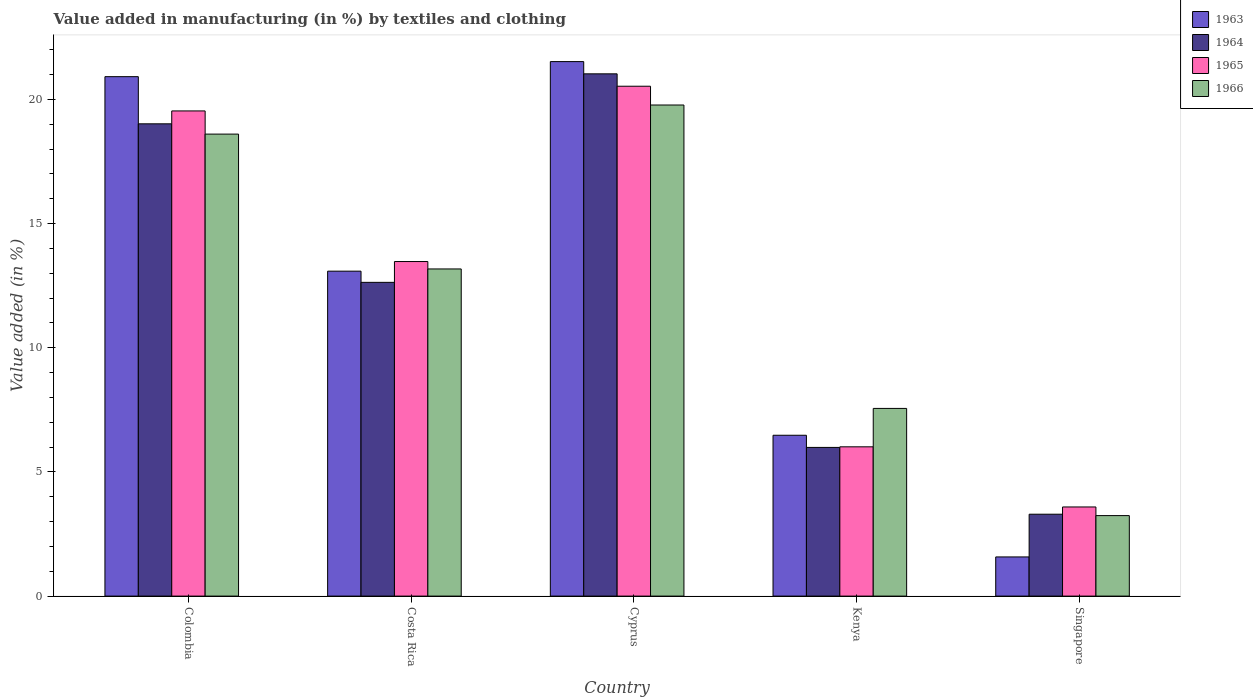How many different coloured bars are there?
Your response must be concise. 4. Are the number of bars per tick equal to the number of legend labels?
Ensure brevity in your answer.  Yes. How many bars are there on the 1st tick from the left?
Your response must be concise. 4. How many bars are there on the 5th tick from the right?
Your answer should be compact. 4. In how many cases, is the number of bars for a given country not equal to the number of legend labels?
Keep it short and to the point. 0. What is the percentage of value added in manufacturing by textiles and clothing in 1966 in Kenya?
Your answer should be very brief. 7.56. Across all countries, what is the maximum percentage of value added in manufacturing by textiles and clothing in 1965?
Keep it short and to the point. 20.53. Across all countries, what is the minimum percentage of value added in manufacturing by textiles and clothing in 1966?
Ensure brevity in your answer.  3.24. In which country was the percentage of value added in manufacturing by textiles and clothing in 1966 maximum?
Provide a short and direct response. Cyprus. In which country was the percentage of value added in manufacturing by textiles and clothing in 1966 minimum?
Offer a terse response. Singapore. What is the total percentage of value added in manufacturing by textiles and clothing in 1965 in the graph?
Keep it short and to the point. 63.14. What is the difference between the percentage of value added in manufacturing by textiles and clothing in 1964 in Colombia and that in Cyprus?
Your response must be concise. -2.01. What is the difference between the percentage of value added in manufacturing by textiles and clothing in 1963 in Costa Rica and the percentage of value added in manufacturing by textiles and clothing in 1964 in Singapore?
Your answer should be very brief. 9.79. What is the average percentage of value added in manufacturing by textiles and clothing in 1965 per country?
Offer a terse response. 12.63. What is the difference between the percentage of value added in manufacturing by textiles and clothing of/in 1964 and percentage of value added in manufacturing by textiles and clothing of/in 1966 in Colombia?
Offer a very short reply. 0.41. What is the ratio of the percentage of value added in manufacturing by textiles and clothing in 1965 in Costa Rica to that in Singapore?
Your response must be concise. 3.75. Is the percentage of value added in manufacturing by textiles and clothing in 1964 in Colombia less than that in Cyprus?
Keep it short and to the point. Yes. Is the difference between the percentage of value added in manufacturing by textiles and clothing in 1964 in Costa Rica and Singapore greater than the difference between the percentage of value added in manufacturing by textiles and clothing in 1966 in Costa Rica and Singapore?
Make the answer very short. No. What is the difference between the highest and the second highest percentage of value added in manufacturing by textiles and clothing in 1964?
Provide a short and direct response. 6.38. What is the difference between the highest and the lowest percentage of value added in manufacturing by textiles and clothing in 1964?
Provide a short and direct response. 17.73. Is the sum of the percentage of value added in manufacturing by textiles and clothing in 1965 in Colombia and Cyprus greater than the maximum percentage of value added in manufacturing by textiles and clothing in 1964 across all countries?
Your answer should be very brief. Yes. Is it the case that in every country, the sum of the percentage of value added in manufacturing by textiles and clothing in 1963 and percentage of value added in manufacturing by textiles and clothing in 1964 is greater than the sum of percentage of value added in manufacturing by textiles and clothing in 1966 and percentage of value added in manufacturing by textiles and clothing in 1965?
Provide a short and direct response. No. What does the 4th bar from the right in Cyprus represents?
Provide a succinct answer. 1963. How many countries are there in the graph?
Your answer should be compact. 5. Does the graph contain any zero values?
Offer a very short reply. No. Does the graph contain grids?
Provide a succinct answer. No. How are the legend labels stacked?
Your answer should be compact. Vertical. What is the title of the graph?
Offer a terse response. Value added in manufacturing (in %) by textiles and clothing. Does "1975" appear as one of the legend labels in the graph?
Ensure brevity in your answer.  No. What is the label or title of the X-axis?
Provide a short and direct response. Country. What is the label or title of the Y-axis?
Your answer should be very brief. Value added (in %). What is the Value added (in %) in 1963 in Colombia?
Provide a succinct answer. 20.92. What is the Value added (in %) of 1964 in Colombia?
Your response must be concise. 19.02. What is the Value added (in %) of 1965 in Colombia?
Ensure brevity in your answer.  19.54. What is the Value added (in %) in 1966 in Colombia?
Offer a very short reply. 18.6. What is the Value added (in %) in 1963 in Costa Rica?
Offer a terse response. 13.08. What is the Value added (in %) in 1964 in Costa Rica?
Keep it short and to the point. 12.63. What is the Value added (in %) of 1965 in Costa Rica?
Provide a short and direct response. 13.47. What is the Value added (in %) in 1966 in Costa Rica?
Offer a terse response. 13.17. What is the Value added (in %) of 1963 in Cyprus?
Make the answer very short. 21.52. What is the Value added (in %) in 1964 in Cyprus?
Provide a succinct answer. 21.03. What is the Value added (in %) in 1965 in Cyprus?
Your answer should be very brief. 20.53. What is the Value added (in %) in 1966 in Cyprus?
Your answer should be very brief. 19.78. What is the Value added (in %) in 1963 in Kenya?
Offer a terse response. 6.48. What is the Value added (in %) of 1964 in Kenya?
Offer a very short reply. 5.99. What is the Value added (in %) in 1965 in Kenya?
Offer a terse response. 6.01. What is the Value added (in %) in 1966 in Kenya?
Provide a succinct answer. 7.56. What is the Value added (in %) of 1963 in Singapore?
Provide a succinct answer. 1.58. What is the Value added (in %) of 1964 in Singapore?
Give a very brief answer. 3.3. What is the Value added (in %) in 1965 in Singapore?
Your answer should be compact. 3.59. What is the Value added (in %) of 1966 in Singapore?
Offer a very short reply. 3.24. Across all countries, what is the maximum Value added (in %) of 1963?
Give a very brief answer. 21.52. Across all countries, what is the maximum Value added (in %) in 1964?
Provide a succinct answer. 21.03. Across all countries, what is the maximum Value added (in %) of 1965?
Offer a terse response. 20.53. Across all countries, what is the maximum Value added (in %) of 1966?
Make the answer very short. 19.78. Across all countries, what is the minimum Value added (in %) in 1963?
Your response must be concise. 1.58. Across all countries, what is the minimum Value added (in %) in 1964?
Make the answer very short. 3.3. Across all countries, what is the minimum Value added (in %) in 1965?
Your answer should be compact. 3.59. Across all countries, what is the minimum Value added (in %) in 1966?
Provide a succinct answer. 3.24. What is the total Value added (in %) of 1963 in the graph?
Offer a terse response. 63.58. What is the total Value added (in %) in 1964 in the graph?
Your answer should be very brief. 61.97. What is the total Value added (in %) in 1965 in the graph?
Provide a short and direct response. 63.14. What is the total Value added (in %) of 1966 in the graph?
Ensure brevity in your answer.  62.35. What is the difference between the Value added (in %) in 1963 in Colombia and that in Costa Rica?
Keep it short and to the point. 7.83. What is the difference between the Value added (in %) in 1964 in Colombia and that in Costa Rica?
Provide a succinct answer. 6.38. What is the difference between the Value added (in %) of 1965 in Colombia and that in Costa Rica?
Keep it short and to the point. 6.06. What is the difference between the Value added (in %) of 1966 in Colombia and that in Costa Rica?
Offer a terse response. 5.43. What is the difference between the Value added (in %) of 1963 in Colombia and that in Cyprus?
Offer a terse response. -0.61. What is the difference between the Value added (in %) of 1964 in Colombia and that in Cyprus?
Offer a terse response. -2.01. What is the difference between the Value added (in %) in 1965 in Colombia and that in Cyprus?
Your answer should be very brief. -0.99. What is the difference between the Value added (in %) of 1966 in Colombia and that in Cyprus?
Provide a succinct answer. -1.17. What is the difference between the Value added (in %) of 1963 in Colombia and that in Kenya?
Offer a terse response. 14.44. What is the difference between the Value added (in %) in 1964 in Colombia and that in Kenya?
Make the answer very short. 13.03. What is the difference between the Value added (in %) in 1965 in Colombia and that in Kenya?
Provide a short and direct response. 13.53. What is the difference between the Value added (in %) of 1966 in Colombia and that in Kenya?
Give a very brief answer. 11.05. What is the difference between the Value added (in %) in 1963 in Colombia and that in Singapore?
Ensure brevity in your answer.  19.34. What is the difference between the Value added (in %) of 1964 in Colombia and that in Singapore?
Ensure brevity in your answer.  15.72. What is the difference between the Value added (in %) of 1965 in Colombia and that in Singapore?
Offer a very short reply. 15.95. What is the difference between the Value added (in %) in 1966 in Colombia and that in Singapore?
Give a very brief answer. 15.36. What is the difference between the Value added (in %) in 1963 in Costa Rica and that in Cyprus?
Provide a short and direct response. -8.44. What is the difference between the Value added (in %) in 1964 in Costa Rica and that in Cyprus?
Your answer should be compact. -8.4. What is the difference between the Value added (in %) in 1965 in Costa Rica and that in Cyprus?
Offer a terse response. -7.06. What is the difference between the Value added (in %) in 1966 in Costa Rica and that in Cyprus?
Your answer should be compact. -6.6. What is the difference between the Value added (in %) in 1963 in Costa Rica and that in Kenya?
Provide a succinct answer. 6.61. What is the difference between the Value added (in %) in 1964 in Costa Rica and that in Kenya?
Make the answer very short. 6.65. What is the difference between the Value added (in %) in 1965 in Costa Rica and that in Kenya?
Ensure brevity in your answer.  7.46. What is the difference between the Value added (in %) in 1966 in Costa Rica and that in Kenya?
Provide a short and direct response. 5.62. What is the difference between the Value added (in %) in 1963 in Costa Rica and that in Singapore?
Provide a succinct answer. 11.51. What is the difference between the Value added (in %) in 1964 in Costa Rica and that in Singapore?
Your response must be concise. 9.34. What is the difference between the Value added (in %) in 1965 in Costa Rica and that in Singapore?
Make the answer very short. 9.88. What is the difference between the Value added (in %) of 1966 in Costa Rica and that in Singapore?
Make the answer very short. 9.93. What is the difference between the Value added (in %) in 1963 in Cyprus and that in Kenya?
Provide a succinct answer. 15.05. What is the difference between the Value added (in %) of 1964 in Cyprus and that in Kenya?
Make the answer very short. 15.04. What is the difference between the Value added (in %) in 1965 in Cyprus and that in Kenya?
Give a very brief answer. 14.52. What is the difference between the Value added (in %) in 1966 in Cyprus and that in Kenya?
Offer a terse response. 12.22. What is the difference between the Value added (in %) of 1963 in Cyprus and that in Singapore?
Keep it short and to the point. 19.95. What is the difference between the Value added (in %) in 1964 in Cyprus and that in Singapore?
Offer a very short reply. 17.73. What is the difference between the Value added (in %) of 1965 in Cyprus and that in Singapore?
Your answer should be very brief. 16.94. What is the difference between the Value added (in %) of 1966 in Cyprus and that in Singapore?
Your answer should be very brief. 16.53. What is the difference between the Value added (in %) in 1963 in Kenya and that in Singapore?
Your answer should be compact. 4.9. What is the difference between the Value added (in %) of 1964 in Kenya and that in Singapore?
Offer a very short reply. 2.69. What is the difference between the Value added (in %) in 1965 in Kenya and that in Singapore?
Your answer should be compact. 2.42. What is the difference between the Value added (in %) in 1966 in Kenya and that in Singapore?
Provide a succinct answer. 4.32. What is the difference between the Value added (in %) of 1963 in Colombia and the Value added (in %) of 1964 in Costa Rica?
Provide a short and direct response. 8.28. What is the difference between the Value added (in %) of 1963 in Colombia and the Value added (in %) of 1965 in Costa Rica?
Your answer should be compact. 7.44. What is the difference between the Value added (in %) in 1963 in Colombia and the Value added (in %) in 1966 in Costa Rica?
Your answer should be very brief. 7.74. What is the difference between the Value added (in %) in 1964 in Colombia and the Value added (in %) in 1965 in Costa Rica?
Your answer should be compact. 5.55. What is the difference between the Value added (in %) of 1964 in Colombia and the Value added (in %) of 1966 in Costa Rica?
Your response must be concise. 5.84. What is the difference between the Value added (in %) of 1965 in Colombia and the Value added (in %) of 1966 in Costa Rica?
Keep it short and to the point. 6.36. What is the difference between the Value added (in %) of 1963 in Colombia and the Value added (in %) of 1964 in Cyprus?
Ensure brevity in your answer.  -0.11. What is the difference between the Value added (in %) of 1963 in Colombia and the Value added (in %) of 1965 in Cyprus?
Your response must be concise. 0.39. What is the difference between the Value added (in %) of 1963 in Colombia and the Value added (in %) of 1966 in Cyprus?
Offer a very short reply. 1.14. What is the difference between the Value added (in %) of 1964 in Colombia and the Value added (in %) of 1965 in Cyprus?
Keep it short and to the point. -1.51. What is the difference between the Value added (in %) in 1964 in Colombia and the Value added (in %) in 1966 in Cyprus?
Provide a succinct answer. -0.76. What is the difference between the Value added (in %) in 1965 in Colombia and the Value added (in %) in 1966 in Cyprus?
Give a very brief answer. -0.24. What is the difference between the Value added (in %) of 1963 in Colombia and the Value added (in %) of 1964 in Kenya?
Offer a terse response. 14.93. What is the difference between the Value added (in %) of 1963 in Colombia and the Value added (in %) of 1965 in Kenya?
Keep it short and to the point. 14.91. What is the difference between the Value added (in %) in 1963 in Colombia and the Value added (in %) in 1966 in Kenya?
Your answer should be very brief. 13.36. What is the difference between the Value added (in %) in 1964 in Colombia and the Value added (in %) in 1965 in Kenya?
Your answer should be very brief. 13.01. What is the difference between the Value added (in %) of 1964 in Colombia and the Value added (in %) of 1966 in Kenya?
Offer a very short reply. 11.46. What is the difference between the Value added (in %) of 1965 in Colombia and the Value added (in %) of 1966 in Kenya?
Provide a succinct answer. 11.98. What is the difference between the Value added (in %) in 1963 in Colombia and the Value added (in %) in 1964 in Singapore?
Provide a short and direct response. 17.62. What is the difference between the Value added (in %) in 1963 in Colombia and the Value added (in %) in 1965 in Singapore?
Provide a succinct answer. 17.33. What is the difference between the Value added (in %) in 1963 in Colombia and the Value added (in %) in 1966 in Singapore?
Your answer should be very brief. 17.68. What is the difference between the Value added (in %) of 1964 in Colombia and the Value added (in %) of 1965 in Singapore?
Your response must be concise. 15.43. What is the difference between the Value added (in %) of 1964 in Colombia and the Value added (in %) of 1966 in Singapore?
Your answer should be compact. 15.78. What is the difference between the Value added (in %) in 1965 in Colombia and the Value added (in %) in 1966 in Singapore?
Make the answer very short. 16.3. What is the difference between the Value added (in %) in 1963 in Costa Rica and the Value added (in %) in 1964 in Cyprus?
Offer a very short reply. -7.95. What is the difference between the Value added (in %) of 1963 in Costa Rica and the Value added (in %) of 1965 in Cyprus?
Your response must be concise. -7.45. What is the difference between the Value added (in %) of 1963 in Costa Rica and the Value added (in %) of 1966 in Cyprus?
Make the answer very short. -6.69. What is the difference between the Value added (in %) in 1964 in Costa Rica and the Value added (in %) in 1965 in Cyprus?
Your answer should be compact. -7.9. What is the difference between the Value added (in %) in 1964 in Costa Rica and the Value added (in %) in 1966 in Cyprus?
Make the answer very short. -7.14. What is the difference between the Value added (in %) of 1965 in Costa Rica and the Value added (in %) of 1966 in Cyprus?
Provide a succinct answer. -6.3. What is the difference between the Value added (in %) of 1963 in Costa Rica and the Value added (in %) of 1964 in Kenya?
Your response must be concise. 7.1. What is the difference between the Value added (in %) of 1963 in Costa Rica and the Value added (in %) of 1965 in Kenya?
Your answer should be very brief. 7.07. What is the difference between the Value added (in %) in 1963 in Costa Rica and the Value added (in %) in 1966 in Kenya?
Keep it short and to the point. 5.53. What is the difference between the Value added (in %) of 1964 in Costa Rica and the Value added (in %) of 1965 in Kenya?
Offer a terse response. 6.62. What is the difference between the Value added (in %) of 1964 in Costa Rica and the Value added (in %) of 1966 in Kenya?
Provide a succinct answer. 5.08. What is the difference between the Value added (in %) of 1965 in Costa Rica and the Value added (in %) of 1966 in Kenya?
Your response must be concise. 5.91. What is the difference between the Value added (in %) in 1963 in Costa Rica and the Value added (in %) in 1964 in Singapore?
Ensure brevity in your answer.  9.79. What is the difference between the Value added (in %) in 1963 in Costa Rica and the Value added (in %) in 1965 in Singapore?
Your answer should be very brief. 9.5. What is the difference between the Value added (in %) in 1963 in Costa Rica and the Value added (in %) in 1966 in Singapore?
Your answer should be very brief. 9.84. What is the difference between the Value added (in %) in 1964 in Costa Rica and the Value added (in %) in 1965 in Singapore?
Your answer should be compact. 9.04. What is the difference between the Value added (in %) of 1964 in Costa Rica and the Value added (in %) of 1966 in Singapore?
Provide a short and direct response. 9.39. What is the difference between the Value added (in %) in 1965 in Costa Rica and the Value added (in %) in 1966 in Singapore?
Give a very brief answer. 10.23. What is the difference between the Value added (in %) of 1963 in Cyprus and the Value added (in %) of 1964 in Kenya?
Offer a very short reply. 15.54. What is the difference between the Value added (in %) in 1963 in Cyprus and the Value added (in %) in 1965 in Kenya?
Ensure brevity in your answer.  15.51. What is the difference between the Value added (in %) of 1963 in Cyprus and the Value added (in %) of 1966 in Kenya?
Keep it short and to the point. 13.97. What is the difference between the Value added (in %) of 1964 in Cyprus and the Value added (in %) of 1965 in Kenya?
Give a very brief answer. 15.02. What is the difference between the Value added (in %) in 1964 in Cyprus and the Value added (in %) in 1966 in Kenya?
Give a very brief answer. 13.47. What is the difference between the Value added (in %) in 1965 in Cyprus and the Value added (in %) in 1966 in Kenya?
Your answer should be compact. 12.97. What is the difference between the Value added (in %) in 1963 in Cyprus and the Value added (in %) in 1964 in Singapore?
Provide a short and direct response. 18.23. What is the difference between the Value added (in %) of 1963 in Cyprus and the Value added (in %) of 1965 in Singapore?
Your answer should be very brief. 17.93. What is the difference between the Value added (in %) in 1963 in Cyprus and the Value added (in %) in 1966 in Singapore?
Your answer should be very brief. 18.28. What is the difference between the Value added (in %) of 1964 in Cyprus and the Value added (in %) of 1965 in Singapore?
Ensure brevity in your answer.  17.44. What is the difference between the Value added (in %) of 1964 in Cyprus and the Value added (in %) of 1966 in Singapore?
Give a very brief answer. 17.79. What is the difference between the Value added (in %) in 1965 in Cyprus and the Value added (in %) in 1966 in Singapore?
Give a very brief answer. 17.29. What is the difference between the Value added (in %) of 1963 in Kenya and the Value added (in %) of 1964 in Singapore?
Give a very brief answer. 3.18. What is the difference between the Value added (in %) in 1963 in Kenya and the Value added (in %) in 1965 in Singapore?
Give a very brief answer. 2.89. What is the difference between the Value added (in %) in 1963 in Kenya and the Value added (in %) in 1966 in Singapore?
Give a very brief answer. 3.24. What is the difference between the Value added (in %) in 1964 in Kenya and the Value added (in %) in 1965 in Singapore?
Offer a terse response. 2.4. What is the difference between the Value added (in %) of 1964 in Kenya and the Value added (in %) of 1966 in Singapore?
Ensure brevity in your answer.  2.75. What is the difference between the Value added (in %) in 1965 in Kenya and the Value added (in %) in 1966 in Singapore?
Your answer should be very brief. 2.77. What is the average Value added (in %) of 1963 per country?
Your answer should be very brief. 12.72. What is the average Value added (in %) of 1964 per country?
Ensure brevity in your answer.  12.39. What is the average Value added (in %) of 1965 per country?
Provide a succinct answer. 12.63. What is the average Value added (in %) of 1966 per country?
Ensure brevity in your answer.  12.47. What is the difference between the Value added (in %) of 1963 and Value added (in %) of 1964 in Colombia?
Offer a terse response. 1.9. What is the difference between the Value added (in %) of 1963 and Value added (in %) of 1965 in Colombia?
Give a very brief answer. 1.38. What is the difference between the Value added (in %) of 1963 and Value added (in %) of 1966 in Colombia?
Keep it short and to the point. 2.31. What is the difference between the Value added (in %) in 1964 and Value added (in %) in 1965 in Colombia?
Give a very brief answer. -0.52. What is the difference between the Value added (in %) of 1964 and Value added (in %) of 1966 in Colombia?
Make the answer very short. 0.41. What is the difference between the Value added (in %) of 1965 and Value added (in %) of 1966 in Colombia?
Give a very brief answer. 0.93. What is the difference between the Value added (in %) of 1963 and Value added (in %) of 1964 in Costa Rica?
Ensure brevity in your answer.  0.45. What is the difference between the Value added (in %) of 1963 and Value added (in %) of 1965 in Costa Rica?
Your answer should be compact. -0.39. What is the difference between the Value added (in %) in 1963 and Value added (in %) in 1966 in Costa Rica?
Keep it short and to the point. -0.09. What is the difference between the Value added (in %) in 1964 and Value added (in %) in 1965 in Costa Rica?
Give a very brief answer. -0.84. What is the difference between the Value added (in %) in 1964 and Value added (in %) in 1966 in Costa Rica?
Provide a succinct answer. -0.54. What is the difference between the Value added (in %) of 1965 and Value added (in %) of 1966 in Costa Rica?
Offer a very short reply. 0.3. What is the difference between the Value added (in %) in 1963 and Value added (in %) in 1964 in Cyprus?
Provide a succinct answer. 0.49. What is the difference between the Value added (in %) of 1963 and Value added (in %) of 1966 in Cyprus?
Provide a succinct answer. 1.75. What is the difference between the Value added (in %) in 1964 and Value added (in %) in 1965 in Cyprus?
Provide a succinct answer. 0.5. What is the difference between the Value added (in %) in 1964 and Value added (in %) in 1966 in Cyprus?
Make the answer very short. 1.25. What is the difference between the Value added (in %) in 1965 and Value added (in %) in 1966 in Cyprus?
Ensure brevity in your answer.  0.76. What is the difference between the Value added (in %) of 1963 and Value added (in %) of 1964 in Kenya?
Keep it short and to the point. 0.49. What is the difference between the Value added (in %) in 1963 and Value added (in %) in 1965 in Kenya?
Keep it short and to the point. 0.47. What is the difference between the Value added (in %) of 1963 and Value added (in %) of 1966 in Kenya?
Keep it short and to the point. -1.08. What is the difference between the Value added (in %) of 1964 and Value added (in %) of 1965 in Kenya?
Offer a very short reply. -0.02. What is the difference between the Value added (in %) in 1964 and Value added (in %) in 1966 in Kenya?
Ensure brevity in your answer.  -1.57. What is the difference between the Value added (in %) of 1965 and Value added (in %) of 1966 in Kenya?
Keep it short and to the point. -1.55. What is the difference between the Value added (in %) in 1963 and Value added (in %) in 1964 in Singapore?
Provide a short and direct response. -1.72. What is the difference between the Value added (in %) in 1963 and Value added (in %) in 1965 in Singapore?
Offer a very short reply. -2.01. What is the difference between the Value added (in %) in 1963 and Value added (in %) in 1966 in Singapore?
Give a very brief answer. -1.66. What is the difference between the Value added (in %) of 1964 and Value added (in %) of 1965 in Singapore?
Make the answer very short. -0.29. What is the difference between the Value added (in %) of 1964 and Value added (in %) of 1966 in Singapore?
Your response must be concise. 0.06. What is the difference between the Value added (in %) of 1965 and Value added (in %) of 1966 in Singapore?
Provide a short and direct response. 0.35. What is the ratio of the Value added (in %) of 1963 in Colombia to that in Costa Rica?
Provide a succinct answer. 1.6. What is the ratio of the Value added (in %) of 1964 in Colombia to that in Costa Rica?
Your answer should be very brief. 1.51. What is the ratio of the Value added (in %) in 1965 in Colombia to that in Costa Rica?
Make the answer very short. 1.45. What is the ratio of the Value added (in %) of 1966 in Colombia to that in Costa Rica?
Provide a succinct answer. 1.41. What is the ratio of the Value added (in %) in 1963 in Colombia to that in Cyprus?
Keep it short and to the point. 0.97. What is the ratio of the Value added (in %) of 1964 in Colombia to that in Cyprus?
Provide a short and direct response. 0.9. What is the ratio of the Value added (in %) in 1965 in Colombia to that in Cyprus?
Offer a terse response. 0.95. What is the ratio of the Value added (in %) in 1966 in Colombia to that in Cyprus?
Offer a terse response. 0.94. What is the ratio of the Value added (in %) in 1963 in Colombia to that in Kenya?
Your answer should be very brief. 3.23. What is the ratio of the Value added (in %) of 1964 in Colombia to that in Kenya?
Give a very brief answer. 3.18. What is the ratio of the Value added (in %) in 1965 in Colombia to that in Kenya?
Offer a very short reply. 3.25. What is the ratio of the Value added (in %) in 1966 in Colombia to that in Kenya?
Give a very brief answer. 2.46. What is the ratio of the Value added (in %) of 1963 in Colombia to that in Singapore?
Your response must be concise. 13.26. What is the ratio of the Value added (in %) in 1964 in Colombia to that in Singapore?
Your answer should be very brief. 5.77. What is the ratio of the Value added (in %) in 1965 in Colombia to that in Singapore?
Your response must be concise. 5.44. What is the ratio of the Value added (in %) of 1966 in Colombia to that in Singapore?
Your answer should be compact. 5.74. What is the ratio of the Value added (in %) of 1963 in Costa Rica to that in Cyprus?
Ensure brevity in your answer.  0.61. What is the ratio of the Value added (in %) in 1964 in Costa Rica to that in Cyprus?
Ensure brevity in your answer.  0.6. What is the ratio of the Value added (in %) of 1965 in Costa Rica to that in Cyprus?
Offer a terse response. 0.66. What is the ratio of the Value added (in %) of 1966 in Costa Rica to that in Cyprus?
Ensure brevity in your answer.  0.67. What is the ratio of the Value added (in %) of 1963 in Costa Rica to that in Kenya?
Keep it short and to the point. 2.02. What is the ratio of the Value added (in %) in 1964 in Costa Rica to that in Kenya?
Provide a short and direct response. 2.11. What is the ratio of the Value added (in %) in 1965 in Costa Rica to that in Kenya?
Your response must be concise. 2.24. What is the ratio of the Value added (in %) in 1966 in Costa Rica to that in Kenya?
Your response must be concise. 1.74. What is the ratio of the Value added (in %) in 1963 in Costa Rica to that in Singapore?
Your response must be concise. 8.3. What is the ratio of the Value added (in %) of 1964 in Costa Rica to that in Singapore?
Ensure brevity in your answer.  3.83. What is the ratio of the Value added (in %) in 1965 in Costa Rica to that in Singapore?
Ensure brevity in your answer.  3.75. What is the ratio of the Value added (in %) in 1966 in Costa Rica to that in Singapore?
Offer a terse response. 4.06. What is the ratio of the Value added (in %) of 1963 in Cyprus to that in Kenya?
Your response must be concise. 3.32. What is the ratio of the Value added (in %) in 1964 in Cyprus to that in Kenya?
Ensure brevity in your answer.  3.51. What is the ratio of the Value added (in %) of 1965 in Cyprus to that in Kenya?
Your answer should be compact. 3.42. What is the ratio of the Value added (in %) in 1966 in Cyprus to that in Kenya?
Give a very brief answer. 2.62. What is the ratio of the Value added (in %) in 1963 in Cyprus to that in Singapore?
Your answer should be very brief. 13.65. What is the ratio of the Value added (in %) in 1964 in Cyprus to that in Singapore?
Ensure brevity in your answer.  6.38. What is the ratio of the Value added (in %) of 1965 in Cyprus to that in Singapore?
Provide a succinct answer. 5.72. What is the ratio of the Value added (in %) in 1966 in Cyprus to that in Singapore?
Give a very brief answer. 6.1. What is the ratio of the Value added (in %) in 1963 in Kenya to that in Singapore?
Ensure brevity in your answer.  4.11. What is the ratio of the Value added (in %) in 1964 in Kenya to that in Singapore?
Your answer should be very brief. 1.82. What is the ratio of the Value added (in %) in 1965 in Kenya to that in Singapore?
Your response must be concise. 1.67. What is the ratio of the Value added (in %) of 1966 in Kenya to that in Singapore?
Ensure brevity in your answer.  2.33. What is the difference between the highest and the second highest Value added (in %) of 1963?
Offer a terse response. 0.61. What is the difference between the highest and the second highest Value added (in %) in 1964?
Offer a very short reply. 2.01. What is the difference between the highest and the second highest Value added (in %) of 1966?
Give a very brief answer. 1.17. What is the difference between the highest and the lowest Value added (in %) of 1963?
Give a very brief answer. 19.95. What is the difference between the highest and the lowest Value added (in %) of 1964?
Ensure brevity in your answer.  17.73. What is the difference between the highest and the lowest Value added (in %) in 1965?
Make the answer very short. 16.94. What is the difference between the highest and the lowest Value added (in %) in 1966?
Provide a succinct answer. 16.53. 